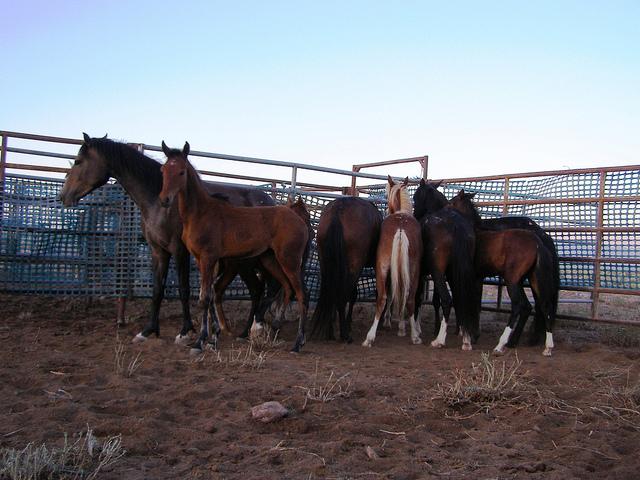How many animals are there?
Be succinct. 7. What are the horses in?
Keep it brief. Corral. How many horses are facing the other way?
Quick response, please. 4. What is the fence made of?
Keep it brief. Metal. 